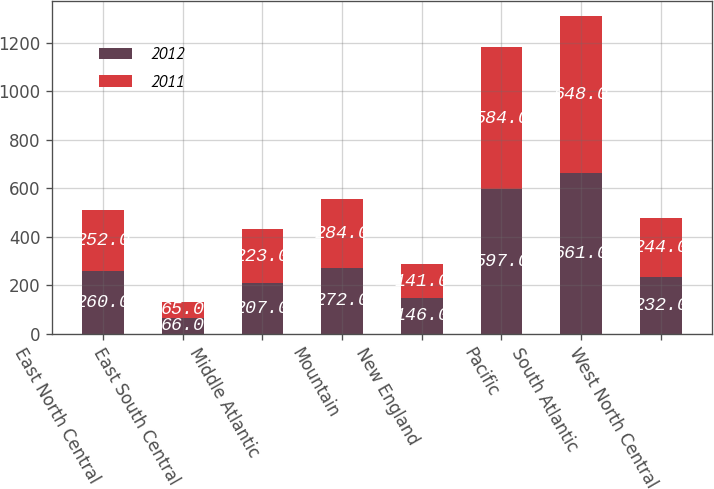Convert chart. <chart><loc_0><loc_0><loc_500><loc_500><stacked_bar_chart><ecel><fcel>East North Central<fcel>East South Central<fcel>Middle Atlantic<fcel>Mountain<fcel>New England<fcel>Pacific<fcel>South Atlantic<fcel>West North Central<nl><fcel>2012<fcel>260<fcel>66<fcel>207<fcel>272<fcel>146<fcel>597<fcel>661<fcel>232<nl><fcel>2011<fcel>252<fcel>65<fcel>223<fcel>284<fcel>141<fcel>584<fcel>648<fcel>244<nl></chart> 